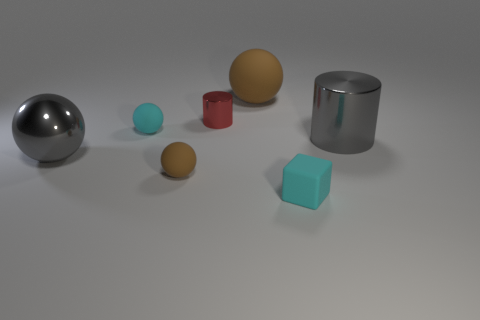Add 1 tiny gray matte objects. How many objects exist? 8 Subtract all cylinders. How many objects are left? 5 Subtract all brown rubber blocks. Subtract all red things. How many objects are left? 6 Add 5 small cyan things. How many small cyan things are left? 7 Add 6 big balls. How many big balls exist? 8 Subtract 0 brown blocks. How many objects are left? 7 